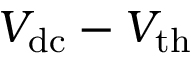Convert formula to latex. <formula><loc_0><loc_0><loc_500><loc_500>V _ { d c } - V _ { t h }</formula> 